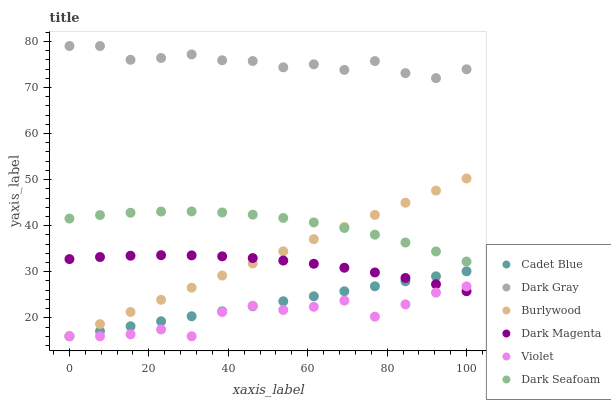Does Violet have the minimum area under the curve?
Answer yes or no. Yes. Does Dark Gray have the maximum area under the curve?
Answer yes or no. Yes. Does Dark Magenta have the minimum area under the curve?
Answer yes or no. No. Does Dark Magenta have the maximum area under the curve?
Answer yes or no. No. Is Cadet Blue the smoothest?
Answer yes or no. Yes. Is Violet the roughest?
Answer yes or no. Yes. Is Dark Magenta the smoothest?
Answer yes or no. No. Is Dark Magenta the roughest?
Answer yes or no. No. Does Cadet Blue have the lowest value?
Answer yes or no. Yes. Does Dark Magenta have the lowest value?
Answer yes or no. No. Does Dark Gray have the highest value?
Answer yes or no. Yes. Does Dark Magenta have the highest value?
Answer yes or no. No. Is Burlywood less than Dark Gray?
Answer yes or no. Yes. Is Dark Gray greater than Dark Seafoam?
Answer yes or no. Yes. Does Violet intersect Burlywood?
Answer yes or no. Yes. Is Violet less than Burlywood?
Answer yes or no. No. Is Violet greater than Burlywood?
Answer yes or no. No. Does Burlywood intersect Dark Gray?
Answer yes or no. No. 